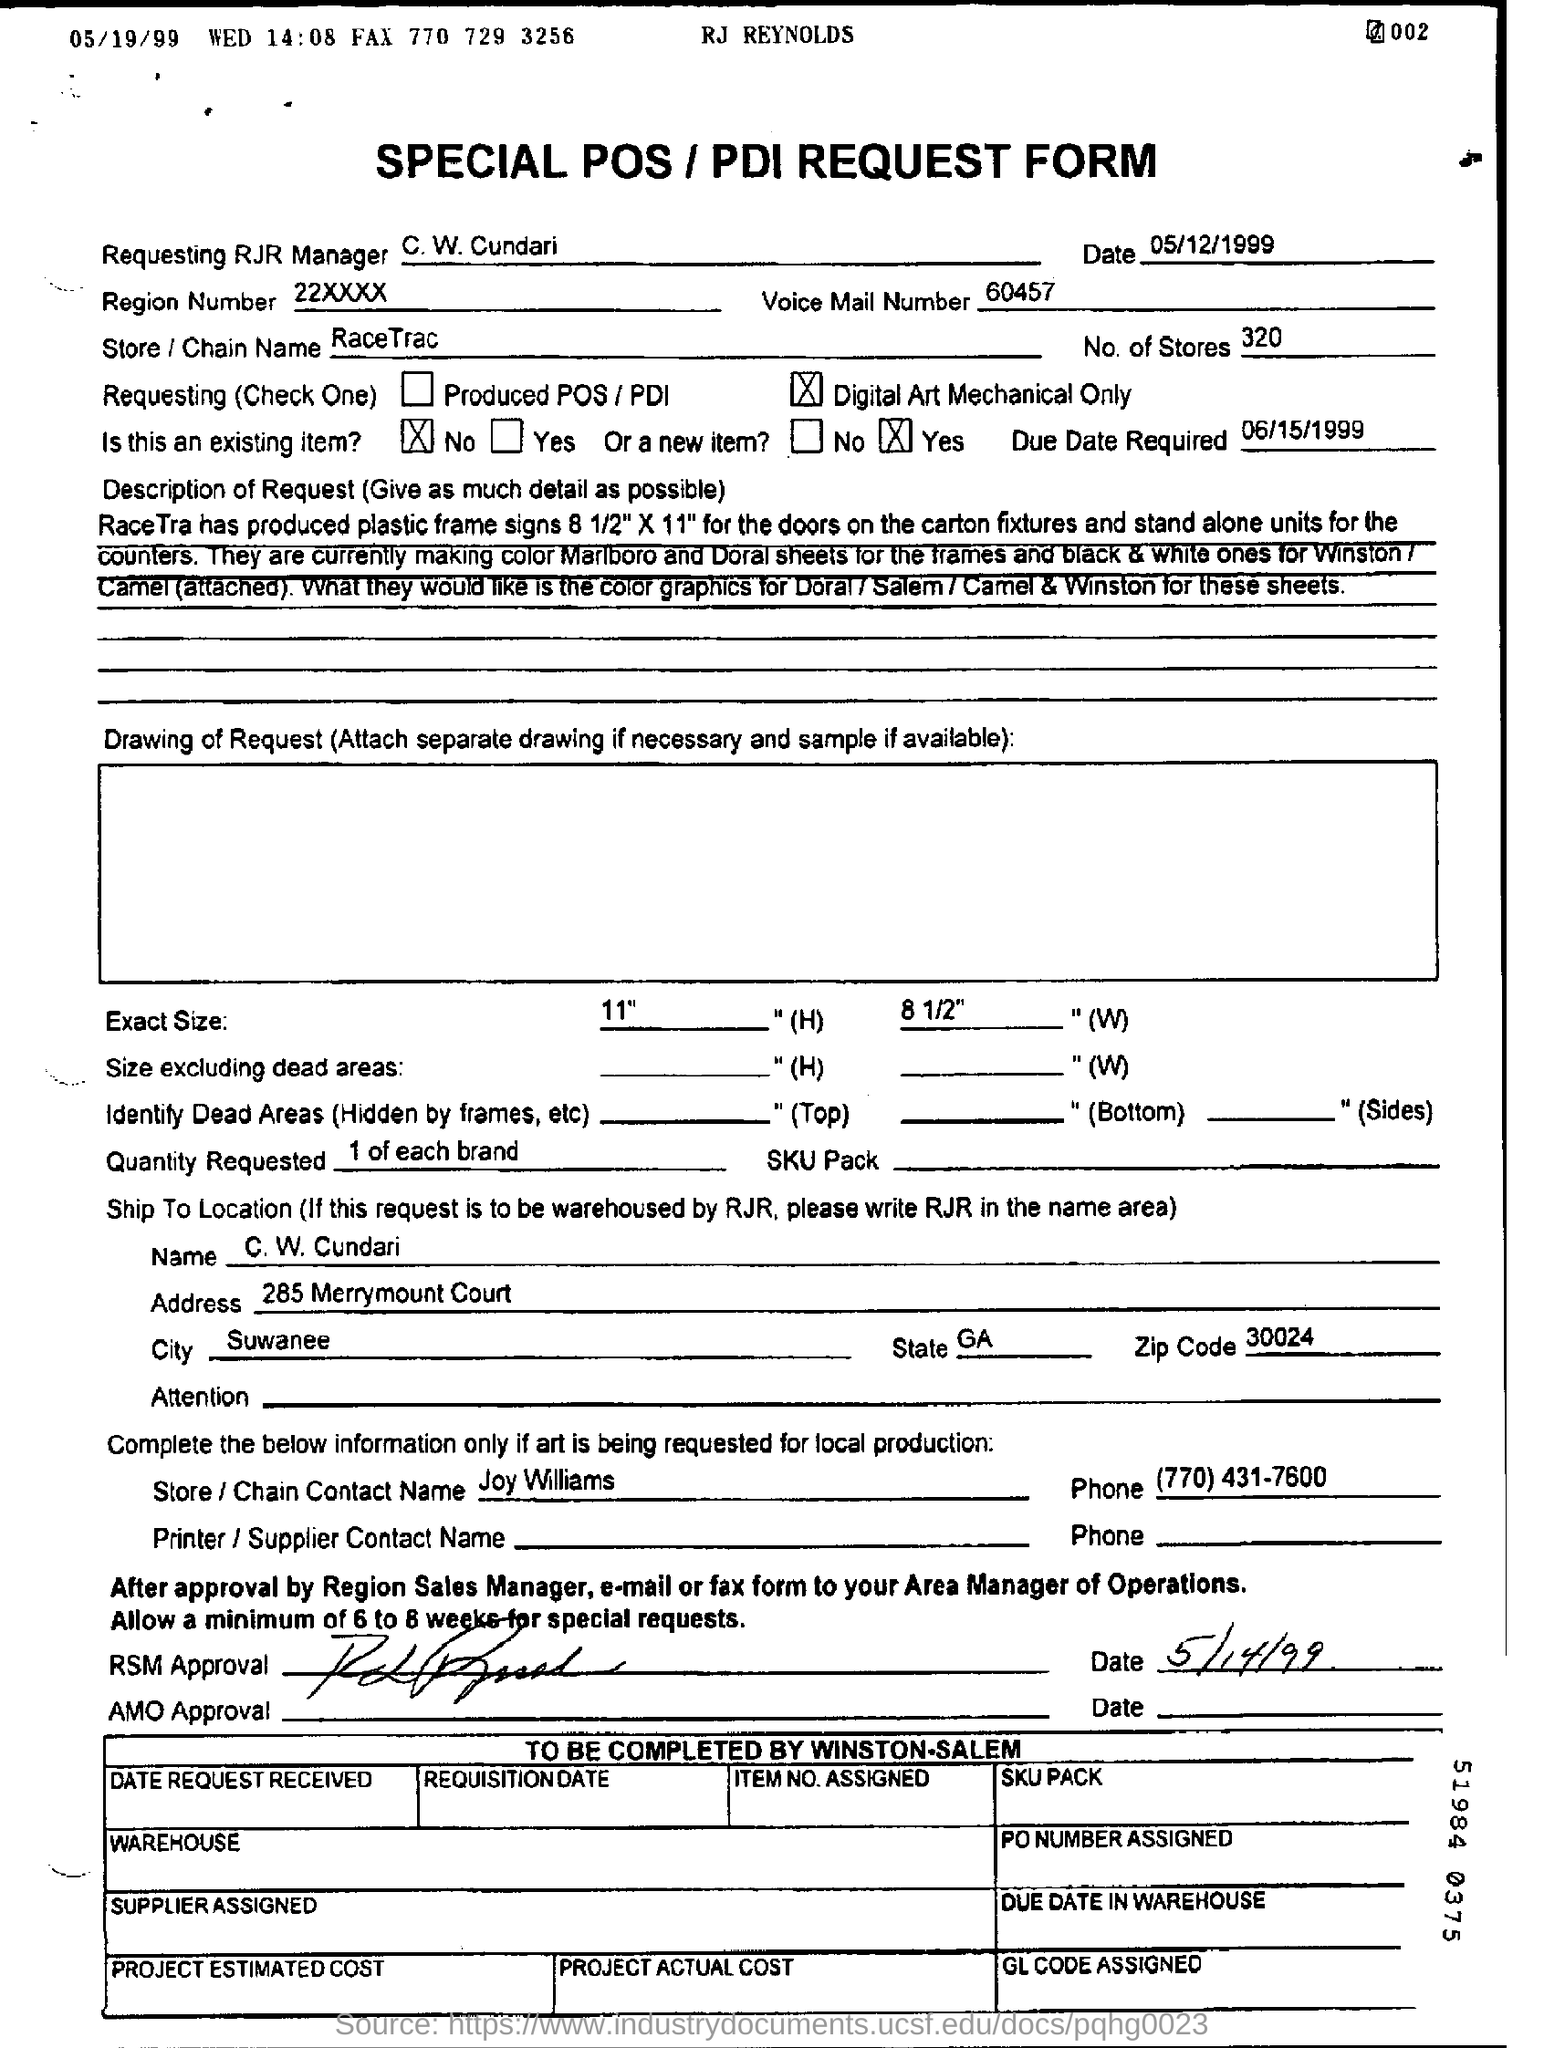What is the name of Requesting RJR Manager?
Keep it short and to the point. C. W. Cundari. When is the form dated?
Provide a succinct answer. 05/12/1999. What is the voice mail number?
Provide a succinct answer. 60457. What is the region number?
Your answer should be very brief. 22XXXX. What is the store/ chain name?
Ensure brevity in your answer.  RaceTrac. When is the Due Date Required?
Provide a succinct answer. 06/15/1999. What is the number of stores mentioned?
Offer a terse response. 320. Who is the Store/ Chain contact name?
Your response must be concise. Joy Williams. 